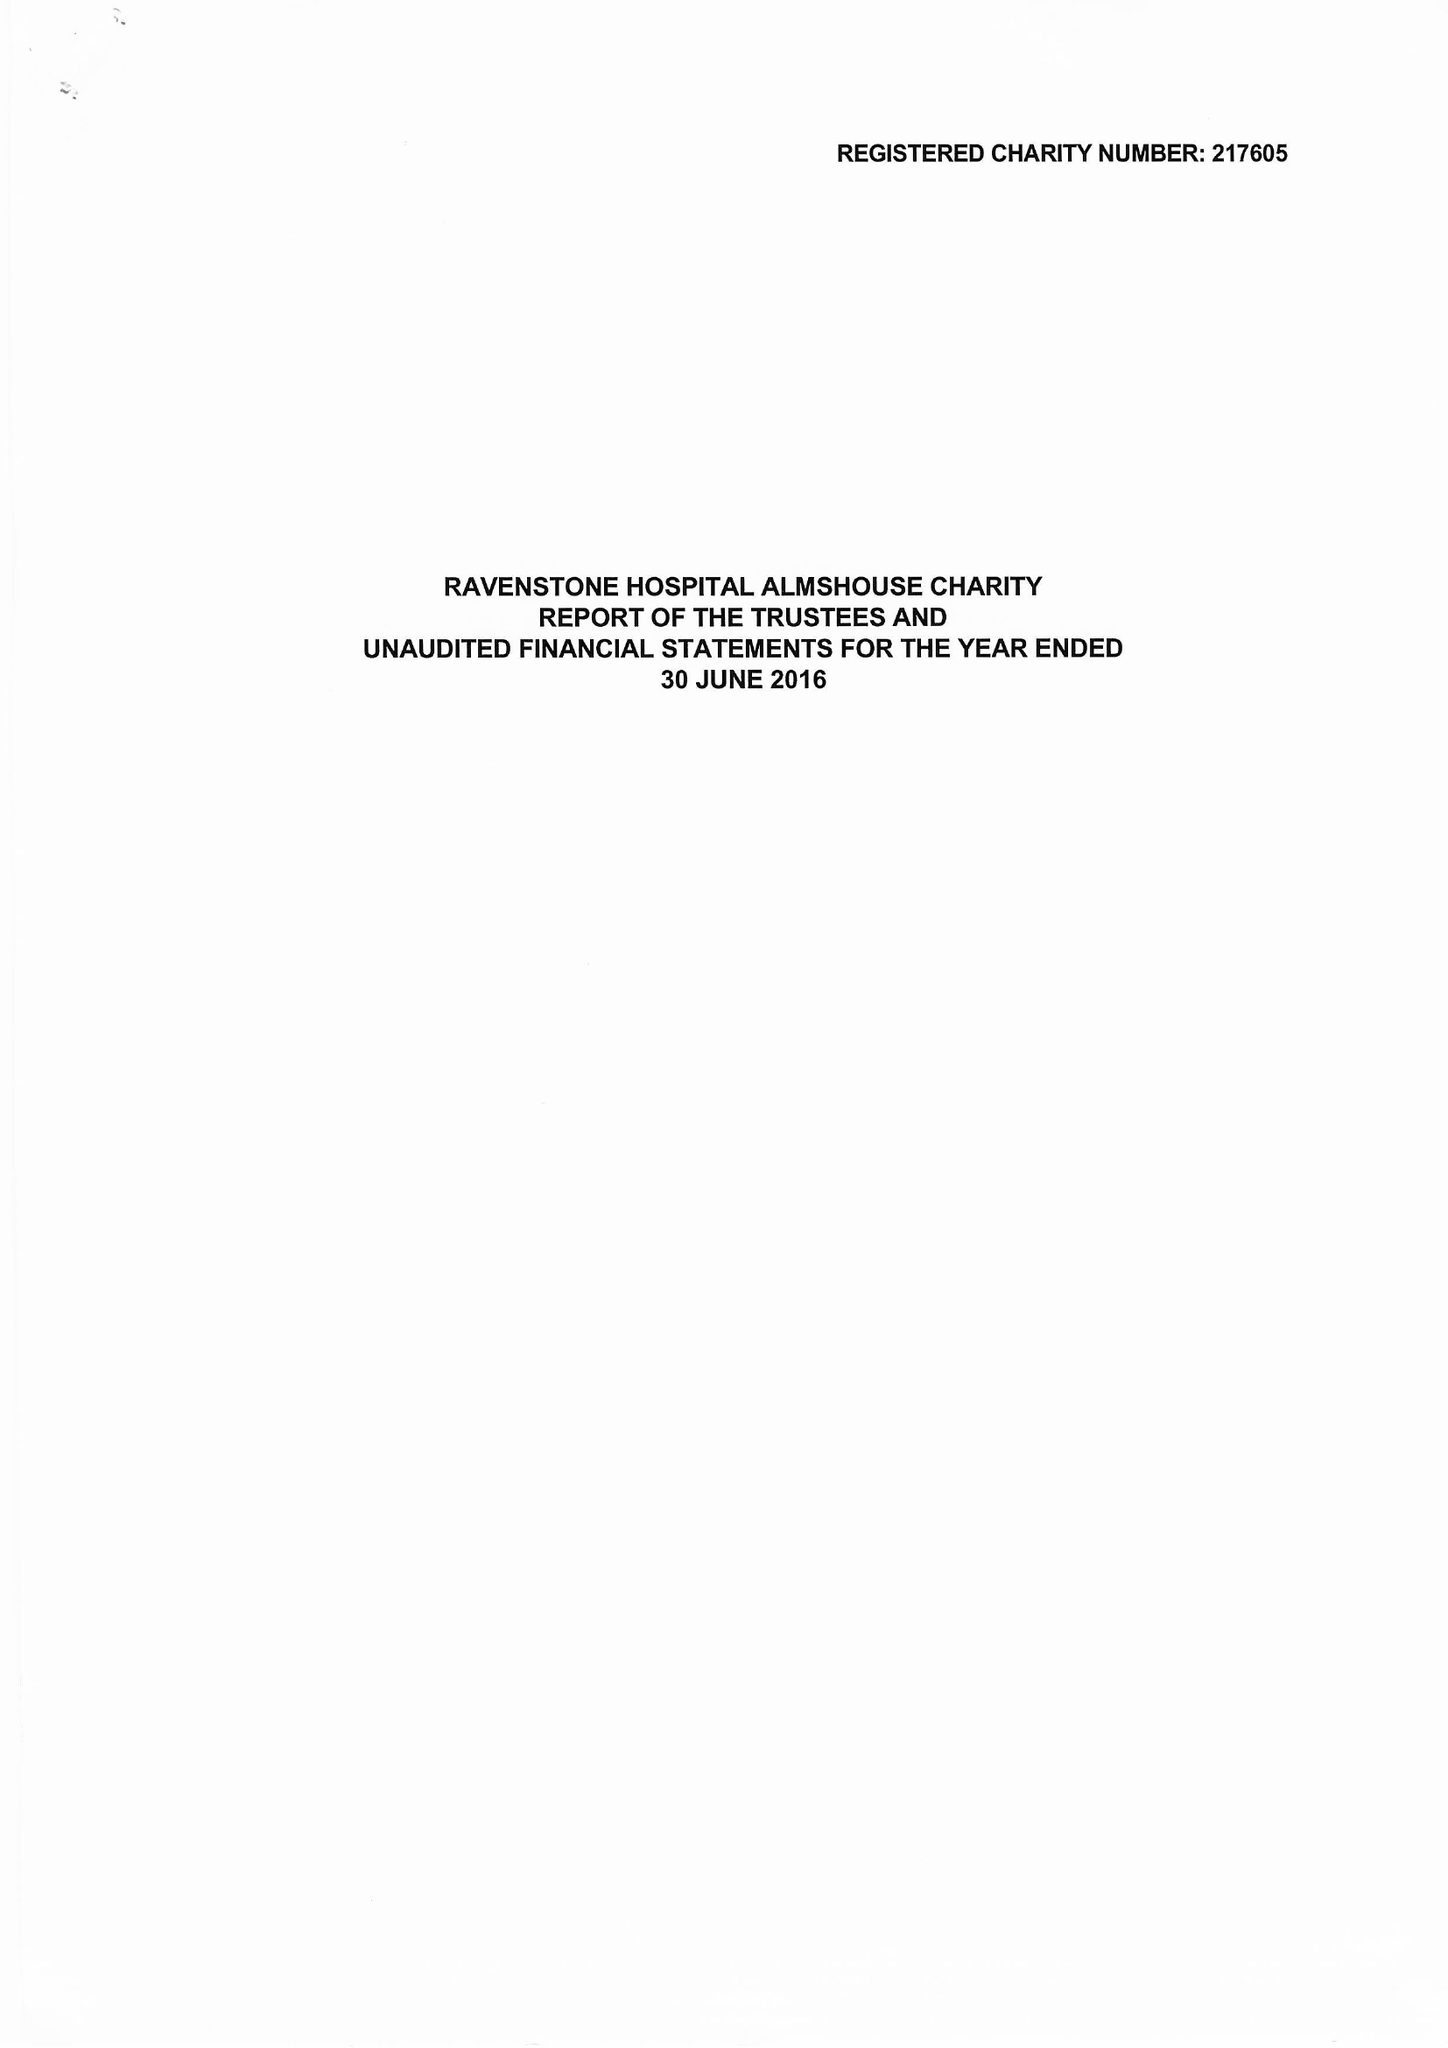What is the value for the address__post_town?
Answer the question using a single word or phrase. DERBY 